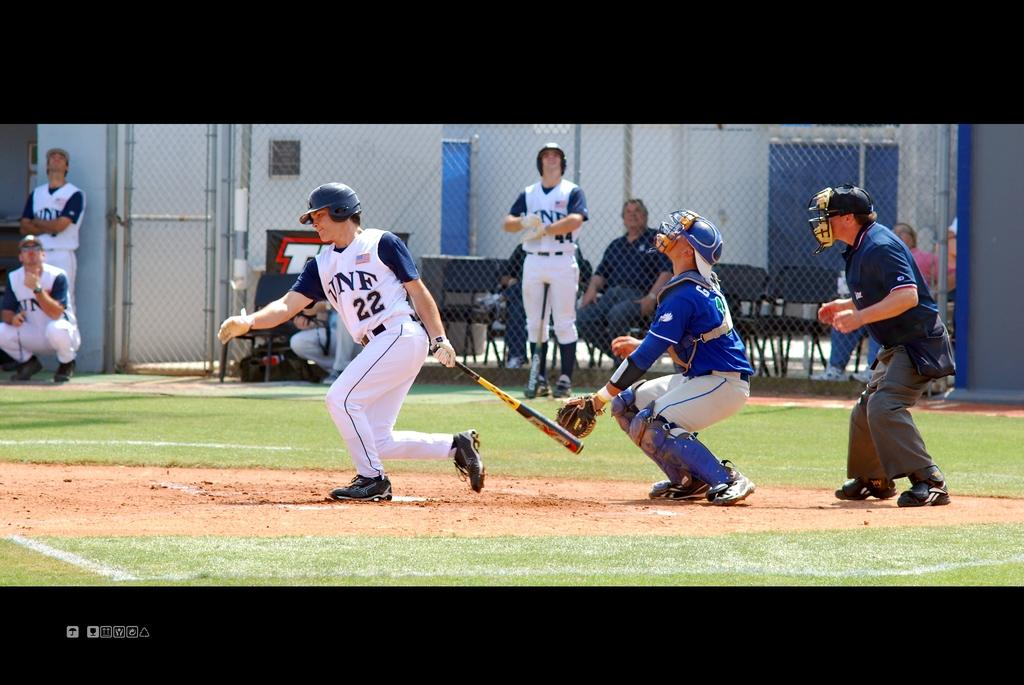<image>
Summarize the visual content of the image. vnf player #22 hits the ball and other vnf players and the catcher look upward to see the ball 